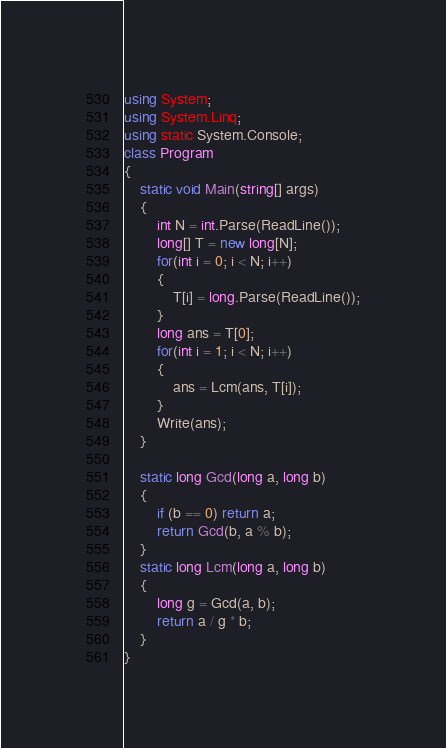<code> <loc_0><loc_0><loc_500><loc_500><_C#_>using System;
using System.Linq;
using static System.Console;
class Program
{
    static void Main(string[] args)
    {
        int N = int.Parse(ReadLine());
        long[] T = new long[N];
        for(int i = 0; i < N; i++)
        {
            T[i] = long.Parse(ReadLine());
        }
        long ans = T[0];
        for(int i = 1; i < N; i++)
        {
            ans = Lcm(ans, T[i]);
        }
        Write(ans);
    }

    static long Gcd(long a, long b)
    {
        if (b == 0) return a;
        return Gcd(b, a % b);
    }
    static long Lcm(long a, long b)
    {
        long g = Gcd(a, b);
        return a / g * b;
    }
}</code> 